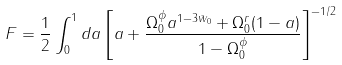Convert formula to latex. <formula><loc_0><loc_0><loc_500><loc_500>F = \frac { 1 } { 2 } \int _ { 0 } ^ { 1 } { d a \left [ a + \frac { \Omega _ { 0 } ^ { \phi } a ^ { 1 - 3 \bar { w } _ { 0 } } + \Omega _ { 0 } ^ { r } ( 1 - a ) } { 1 - \Omega _ { 0 } ^ { \phi } } \right ] ^ { - 1 / 2 } }</formula> 